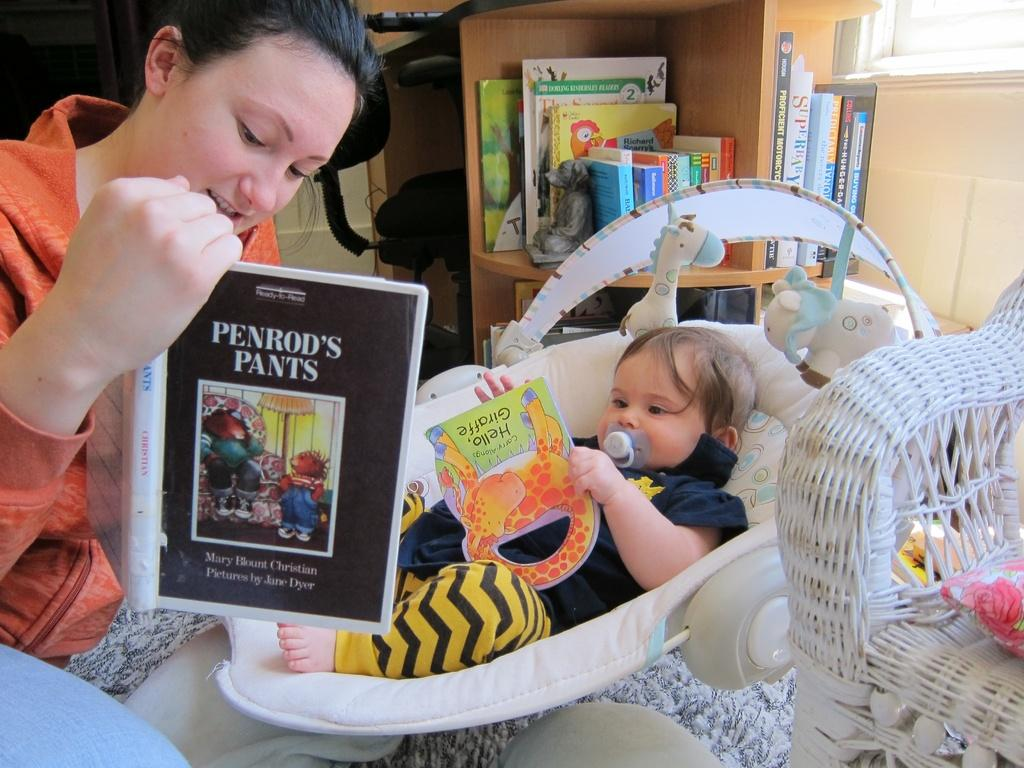What is the main subject in the image? There is a baby in the cradle in the image. Can you describe the lady in the image? There is a lady holding a book on the left side of the image. How many kittens are playing under the tent in the image? There are no kittens or tents present in the image. What statement is being made by the lady in the image? The image does not provide any information about a statement being made by the lady. 